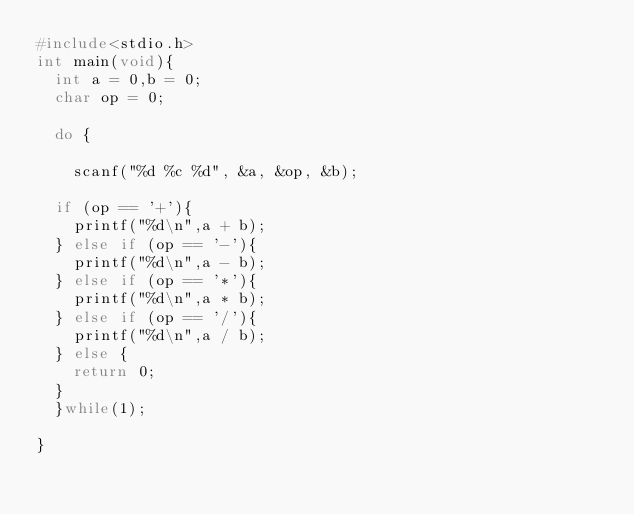Convert code to text. <code><loc_0><loc_0><loc_500><loc_500><_C_>#include<stdio.h>
int main(void){
  int a = 0,b = 0;
  char op = 0;

  do {

    scanf("%d %c %d", &a, &op, &b);

  if (op == '+'){
    printf("%d\n",a + b);
  } else if (op == '-'){
    printf("%d\n",a - b);
  } else if (op == '*'){
    printf("%d\n",a * b);
  } else if (op == '/'){
    printf("%d\n",a / b);
  } else {
    return 0;
  }
  }while(1);

}</code> 